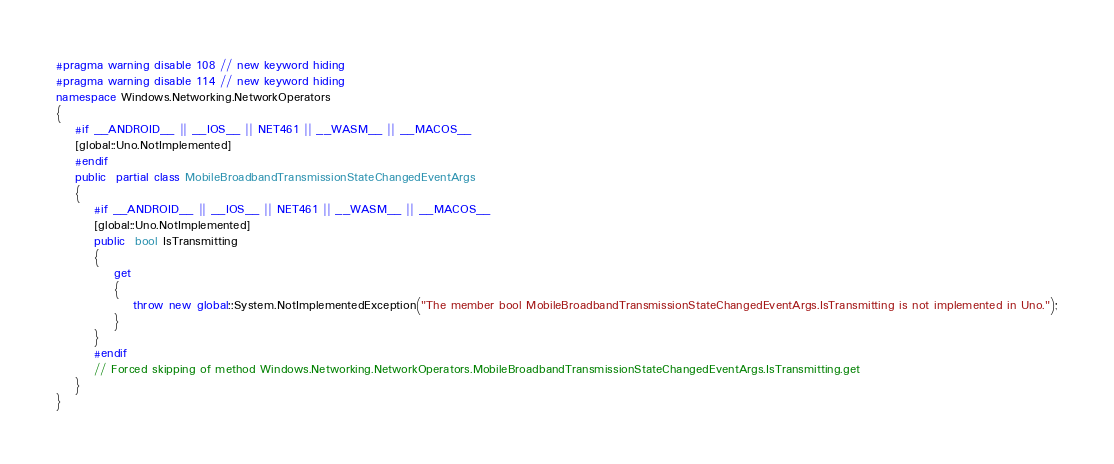Convert code to text. <code><loc_0><loc_0><loc_500><loc_500><_C#_>#pragma warning disable 108 // new keyword hiding
#pragma warning disable 114 // new keyword hiding
namespace Windows.Networking.NetworkOperators
{
	#if __ANDROID__ || __IOS__ || NET461 || __WASM__ || __MACOS__
	[global::Uno.NotImplemented]
	#endif
	public  partial class MobileBroadbandTransmissionStateChangedEventArgs 
	{
		#if __ANDROID__ || __IOS__ || NET461 || __WASM__ || __MACOS__
		[global::Uno.NotImplemented]
		public  bool IsTransmitting
		{
			get
			{
				throw new global::System.NotImplementedException("The member bool MobileBroadbandTransmissionStateChangedEventArgs.IsTransmitting is not implemented in Uno.");
			}
		}
		#endif
		// Forced skipping of method Windows.Networking.NetworkOperators.MobileBroadbandTransmissionStateChangedEventArgs.IsTransmitting.get
	}
}
</code> 